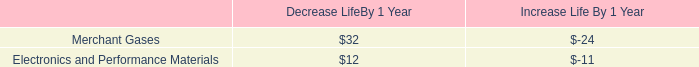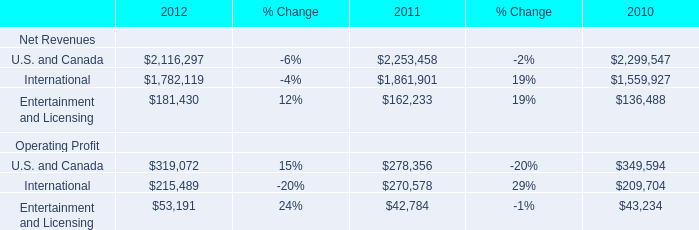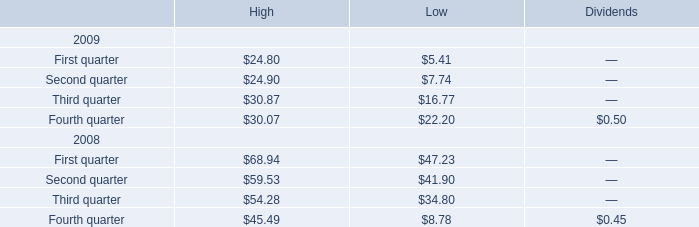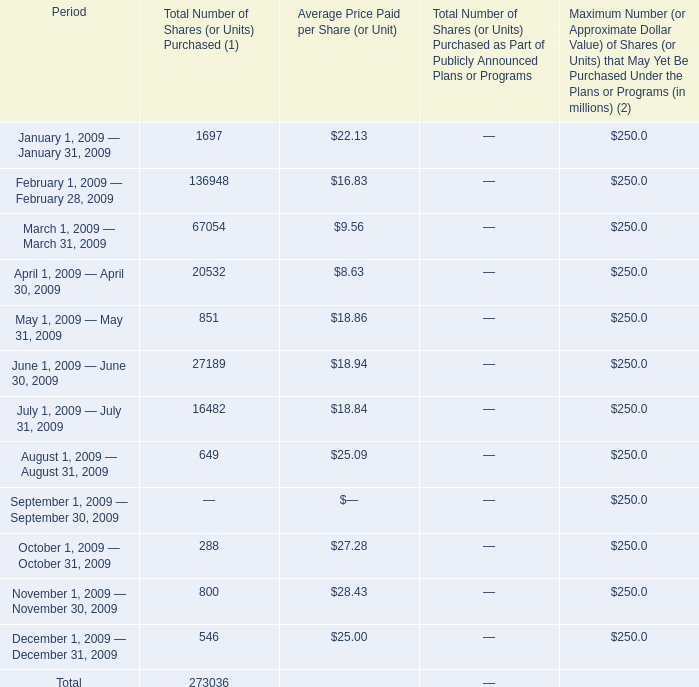what is the highest total amount of Total Number of Shares ? (in million) 
Answer: 136948. 